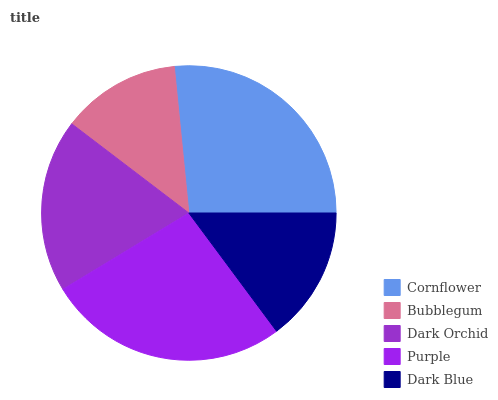Is Bubblegum the minimum?
Answer yes or no. Yes. Is Cornflower the maximum?
Answer yes or no. Yes. Is Dark Orchid the minimum?
Answer yes or no. No. Is Dark Orchid the maximum?
Answer yes or no. No. Is Dark Orchid greater than Bubblegum?
Answer yes or no. Yes. Is Bubblegum less than Dark Orchid?
Answer yes or no. Yes. Is Bubblegum greater than Dark Orchid?
Answer yes or no. No. Is Dark Orchid less than Bubblegum?
Answer yes or no. No. Is Dark Orchid the high median?
Answer yes or no. Yes. Is Dark Orchid the low median?
Answer yes or no. Yes. Is Bubblegum the high median?
Answer yes or no. No. Is Purple the low median?
Answer yes or no. No. 